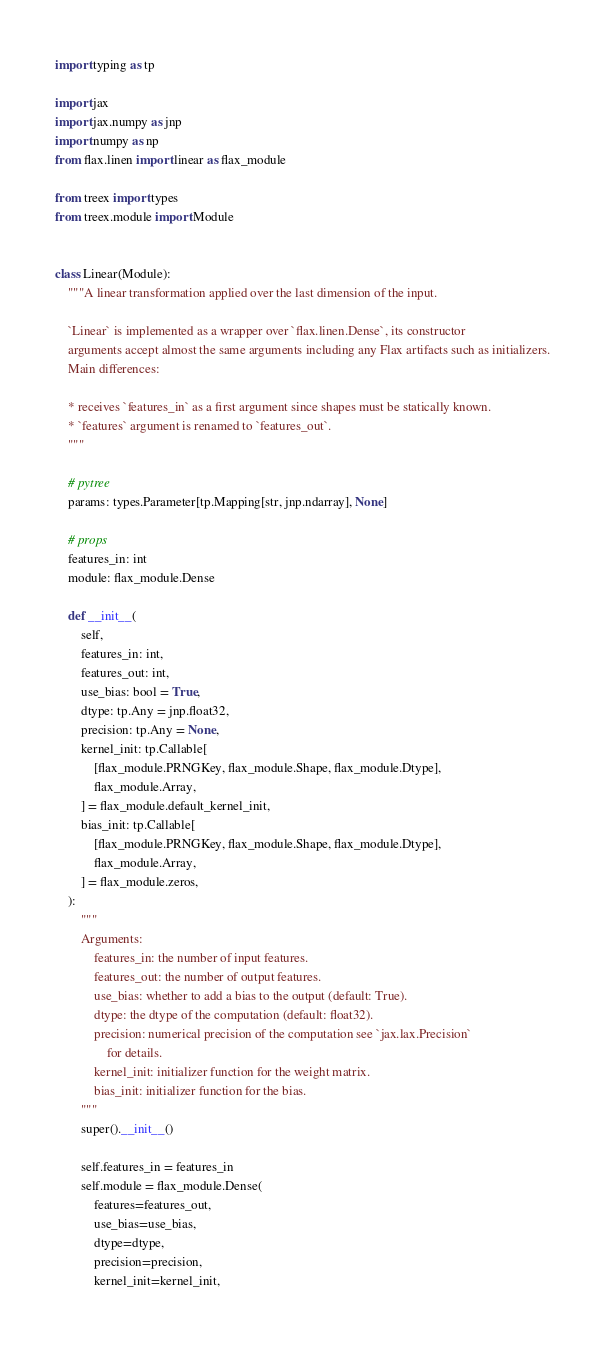Convert code to text. <code><loc_0><loc_0><loc_500><loc_500><_Python_>import typing as tp

import jax
import jax.numpy as jnp
import numpy as np
from flax.linen import linear as flax_module

from treex import types
from treex.module import Module


class Linear(Module):
    """A linear transformation applied over the last dimension of the input.

    `Linear` is implemented as a wrapper over `flax.linen.Dense`, its constructor
    arguments accept almost the same arguments including any Flax artifacts such as initializers.
    Main differences:

    * receives `features_in` as a first argument since shapes must be statically known.
    * `features` argument is renamed to `features_out`.
    """

    # pytree
    params: types.Parameter[tp.Mapping[str, jnp.ndarray], None]

    # props
    features_in: int
    module: flax_module.Dense

    def __init__(
        self,
        features_in: int,
        features_out: int,
        use_bias: bool = True,
        dtype: tp.Any = jnp.float32,
        precision: tp.Any = None,
        kernel_init: tp.Callable[
            [flax_module.PRNGKey, flax_module.Shape, flax_module.Dtype],
            flax_module.Array,
        ] = flax_module.default_kernel_init,
        bias_init: tp.Callable[
            [flax_module.PRNGKey, flax_module.Shape, flax_module.Dtype],
            flax_module.Array,
        ] = flax_module.zeros,
    ):
        """
        Arguments:
            features_in: the number of input features.
            features_out: the number of output features.
            use_bias: whether to add a bias to the output (default: True).
            dtype: the dtype of the computation (default: float32).
            precision: numerical precision of the computation see `jax.lax.Precision`
                for details.
            kernel_init: initializer function for the weight matrix.
            bias_init: initializer function for the bias.
        """
        super().__init__()

        self.features_in = features_in
        self.module = flax_module.Dense(
            features=features_out,
            use_bias=use_bias,
            dtype=dtype,
            precision=precision,
            kernel_init=kernel_init,</code> 